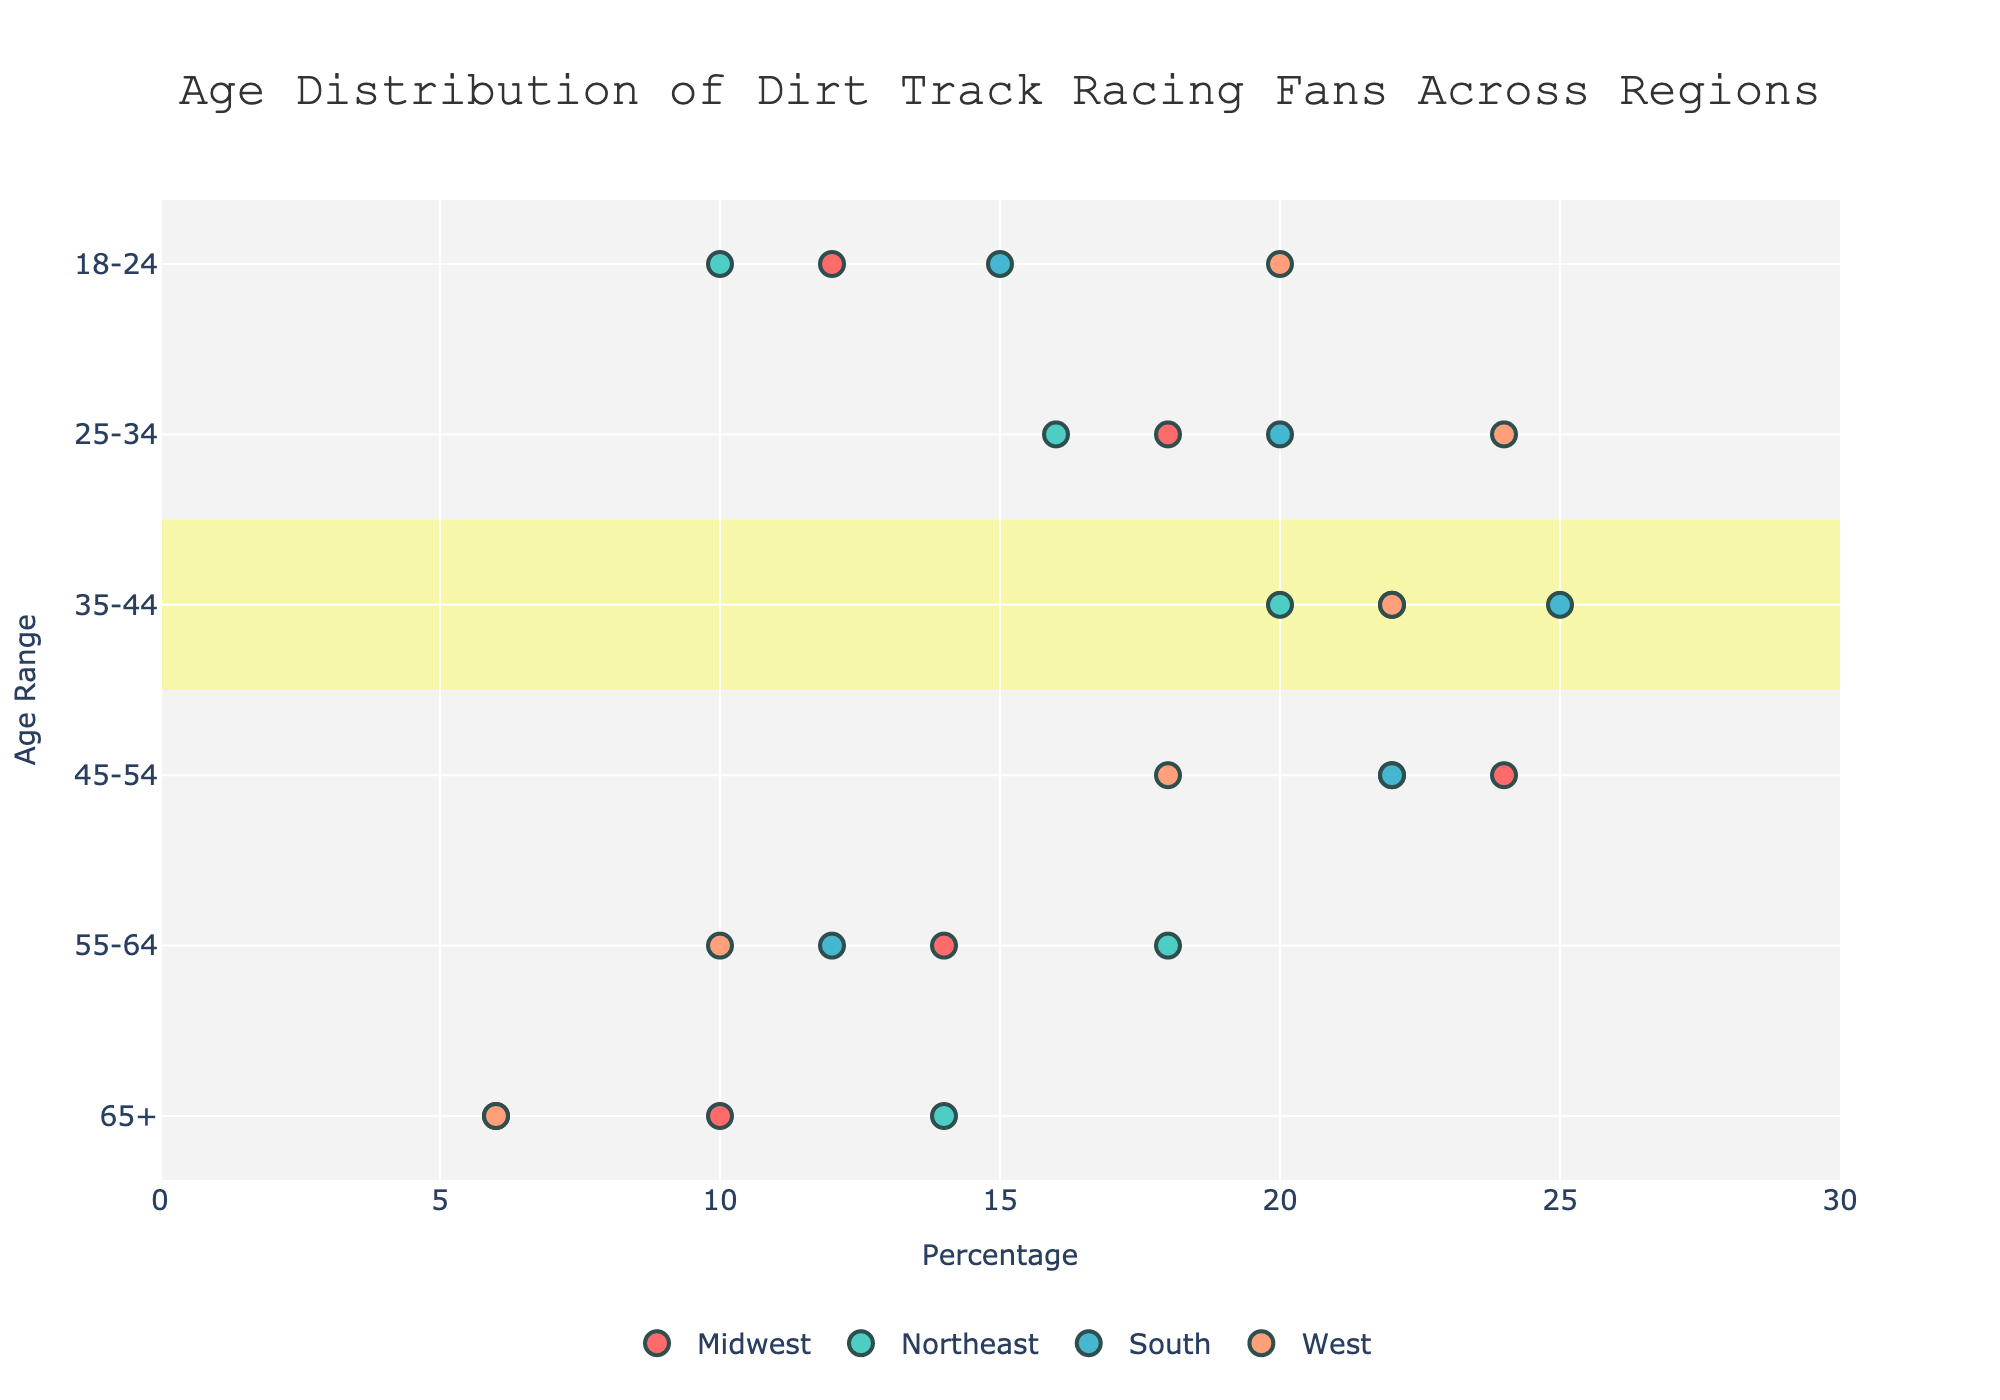What is the title of the figure? The title of the figure can be found at the top of the chart. It reads "Age Distribution of Dirt Track Racing Fans Across Regions."
Answer: Age Distribution of Dirt Track Racing Fans Across Regions How many regions are represented in the figure? The figure contains multiple colored dots, each corresponding to a different region. There are four different colors representing four regions, as indicated by the legend.
Answer: 4 Which age range has the highest percentage of fans in the Midwest? By looking at the x-axis values corresponding to each age range for the Midwest, the highest percentage is seen for the age range 45-54.
Answer: 45-54 Compare the age distribution of fans aged 18-24 in the Midwest and the West. Which region has a higher percentage of fans? By comparing the x-axis values for the age range 18-24, the percentage for the Midwest is 12%, and for the West, it is 20%. The West has a higher percentage of fans in this age range.
Answer: West What is the percentage difference between fans aged 65+ in the Midwest and the South? The percentages for the 65+ age range are 10% for the Midwest and 6% for the South. The difference is calculated by subtracting the smaller percentage from the larger one: 10% - 6% = 4%.
Answer: 4% In which region is the age range 55-64 more prevalent, the Northeast or the South? By comparing the x-axis values for this age range, the percentage for the Northeast is 18%, and for the South, it is 12%. The Northeast has a higher percentage of fans in this age range.
Answer: Northeast What is the average percentage of fans aged 35-44 across all regions? To find this, add the percentages for each region in the 35-44 age range and divide by the number of regions: (22% + 20% + 25% + 22%) / 4 = 22.25%.
Answer: 22.25% Which age range is highlighted as the most common across regions, and why is it highlighted? The age range 35-44 is highlighted with a yellow rectangle. This annotation indicates that it is the most common age range across all regions, based on the visual cue provided.
Answer: 35-44 In the South region, how many percentage points more prevalent are fans aged 35-44 compared to those aged 65+? The percentage for fans aged 35-44 in the South is 25%, and for those aged 65+, it is 6%. The difference is 25% - 6% = 19 percentage points.
Answer: 19 Which region has the broadest age distribution of fans, and how can you tell? The broadest age distribution can be determined by examining the range of percentages across all age groups within each region. The Midwest region has a more evenly spread distribution across age ranges, suggesting a broad age distribution.
Answer: Midwest 